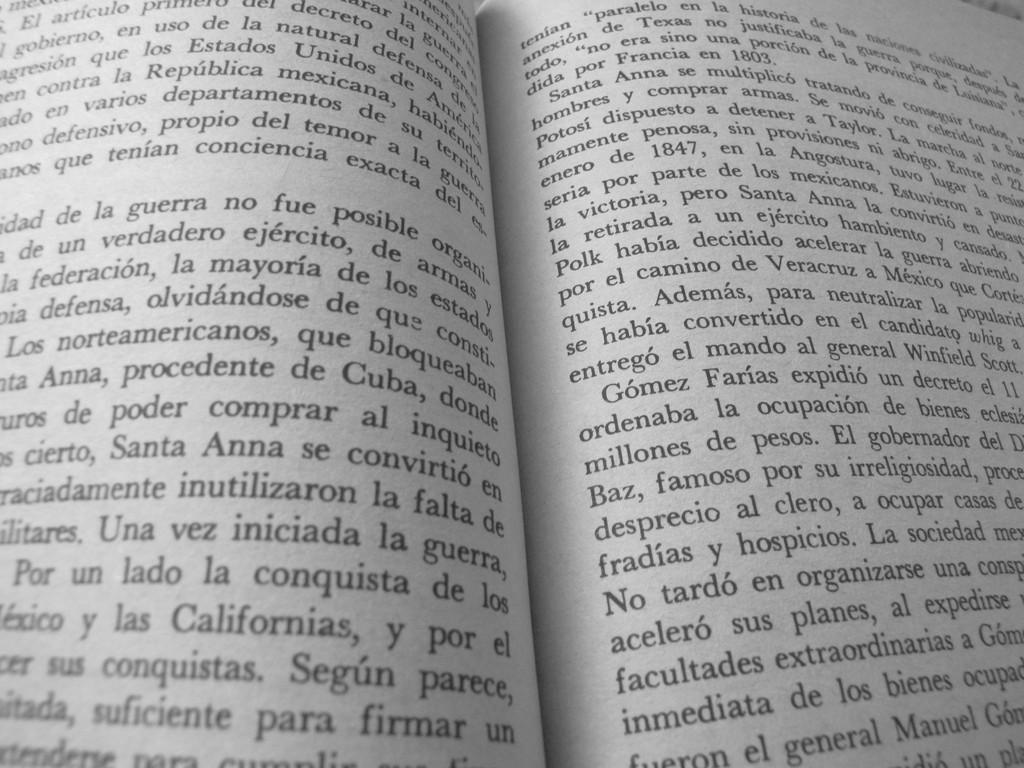Provide a one-sentence caption for the provided image. a book in spanish is open to a page talking about las Californias. 